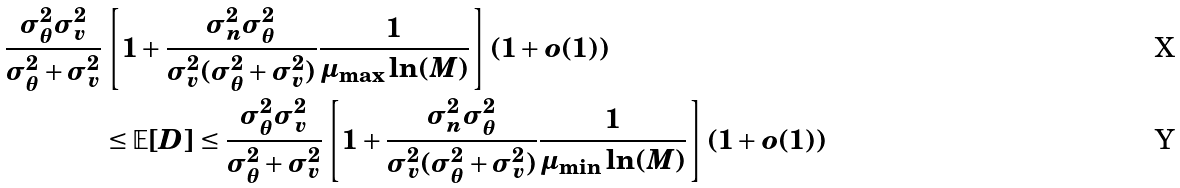<formula> <loc_0><loc_0><loc_500><loc_500>\frac { \sigma _ { \theta } ^ { 2 } \sigma _ { v } ^ { 2 } } { \sigma _ { \theta } ^ { 2 } + \sigma _ { v } ^ { 2 } } & \left [ 1 + \frac { \sigma _ { n } ^ { 2 } \sigma _ { \theta } ^ { 2 } } { \sigma _ { v } ^ { 2 } ( \sigma _ { \theta } ^ { 2 } + \sigma _ { v } ^ { 2 } ) } \frac { 1 } { \mu _ { \max } \ln ( M ) } \right ] ( 1 + o ( 1 ) ) \\ & \leq \mathbb { E } [ D ] \leq \frac { \sigma _ { \theta } ^ { 2 } \sigma _ { v } ^ { 2 } } { \sigma _ { \theta } ^ { 2 } + \sigma _ { v } ^ { 2 } } \left [ 1 + \frac { \sigma _ { n } ^ { 2 } \sigma _ { \theta } ^ { 2 } } { \sigma _ { v } ^ { 2 } ( \sigma _ { \theta } ^ { 2 } + \sigma _ { v } ^ { 2 } ) } \frac { 1 } { \mu _ { \min } \ln ( M ) } \right ] ( 1 + o ( 1 ) )</formula> 